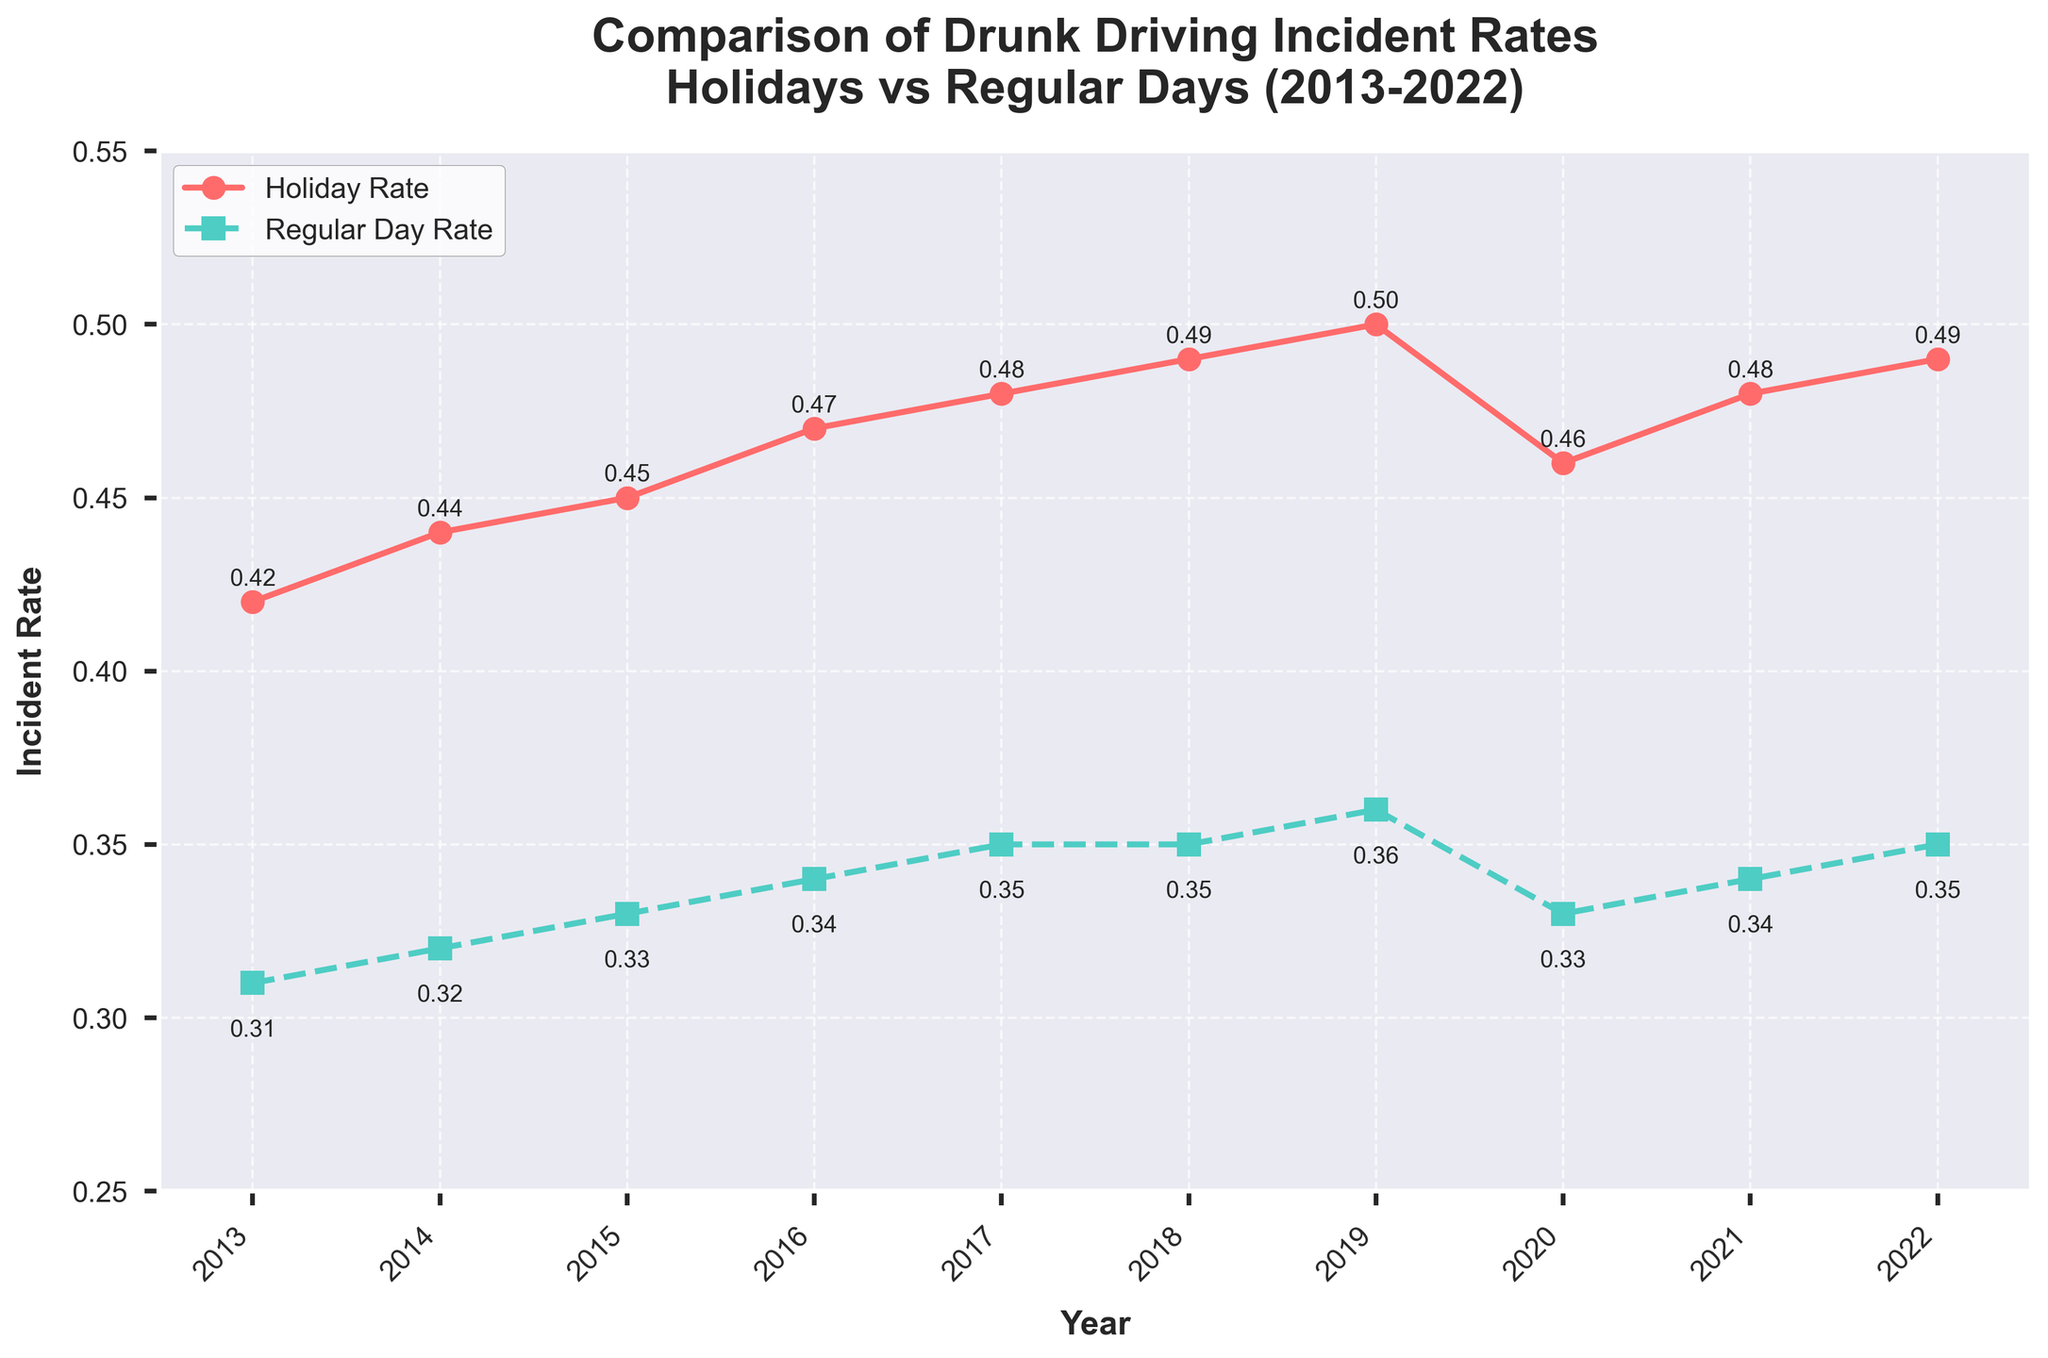What's the trend of drunk driving incident rates during holidays from 2013 to 2022? The line representing the holiday rates shows a consistent upward trend from 2013 to 2019, with a slight dip in 2020, followed by an increase again through 2022. This indicates that the incident rate generally increased over the period, with a small drop in 2020.
Answer: Upward trend with a dip in 2020 How does the trend of regular day incident rates from 2013 to 2022 compare to that of holiday rates? Both holiday and regular day rates show an upward trend over the years. However, the increase is more pronounced for holiday rates. Regular day rates also dipped slightly in 2020 and then resumed their upward trend.
Answer: Both increase, but holiday rates are steeper What was the highest year-over-year increase for holiday rates? To find the highest year-over-year increase, calculate the differences for each year: 2014-2013: 0.44-0.42=0.02, 2015-2014: 0.45-0.44=0.01, 2016-2015: 0.47-0.45=0.02, 2017-2016: 0.48-0.47=0.01, 2018-2017: 0.49-0.48=0.01, 2019-2018: 0.50-0.49=0.01, 2020-2019: 0.46-0.50=-0.04, 2021-2020: 0.48-0.46=0.02, 2022-2021: 0.49-0.48=0.01. The highest increase was 0.02, occurring in 2014-2013, 2016-2015, and 2021-2020.
Answer: 0.02 Which year had the smallest difference between holiday and regular day rates? Calculate the differences for each year: 2013: 0.42-0.31=0.11, 2014: 0.44-0.32=0.12, 2015: 0.45-0.33=0.12, 2016: 0.47-0.34=0.13, 2017: 0.48-0.35=0.13, 2018: 0.49-0.35=0.14, 2019: 0.50-0.36=0.14, 2020: 0.46-0.33=0.13, 2021: 0.48-0.34=0.14, 2022: 0.49-0.35=0.14. The smallest difference was 0.11 in 2013.
Answer: 2013 By how much did the holiday incident rate increase from 2013 to 2022? To find the increase, subtract the 2013 rate from the 2022 rate: 0.49 - 0.42 = 0.07.
Answer: 0.07 What is the average rate of drunk driving incidents during regular days over the given period? Sum up the regular day rates and divide by the number of years: (0.31 + 0.32 + 0.33 + 0.34 + 0.35 + 0.35 + 0.36 + 0.33 + 0.34 + 0.35) / 10 = 3.38 / 10 = 0.338.
Answer: 0.338 In which year was the gap between holiday and regular day rates largest? Calculate the differences for each year: 2013: 0.42-0.31=0.11, 2014: 0.44-0.32=0.12, 2015: 0.45-0.33=0.12, 2016: 0.47-0.34=0.13, 2017: 0.48-0.35=0.13, 2018: 0.49-0.35=0.14, 2019: 0.50-0.36=0.14, 2020: 0.46-0.33=0.13, 2021: 0.48-0.34=0.14, 2022: 0.49-0.35=0.14. The largest gap was 0.14, occurring in the years 2018, 2019, 2021, 2022.
Answer: 2018, 2019, 2021, 2022 Where is the rate higher: on holidays or regular days? By visually inspecting the line chart, the holiday rates consistently remain higher than the regular day rates across all the years.
Answer: Holidays During which year did the regular day rate see the highest year-over-year increase? Calculate the year-over-year differences for regular day rates: 2014-2013: 0.32-0.31=0.01, 2015-2014: 0.33-0.32=0.01, 2016-2015: 0.34-0.33=0.01, 2017-2016: 0.35-0.34=0.01, 2018-2017: 0.35-0.35=0, 2019-2018: 0.36-0.35=0.01, 2020-2019: 0.33-0.36=-0.03, 2021-2020: 0.34-0.33=0.01, 2022-2021: 0.35-0.34=0.01. Since these are all the same, the highest year-over-year increase was 0.01 in multiple years.
Answer: 0.01 in multiple years 